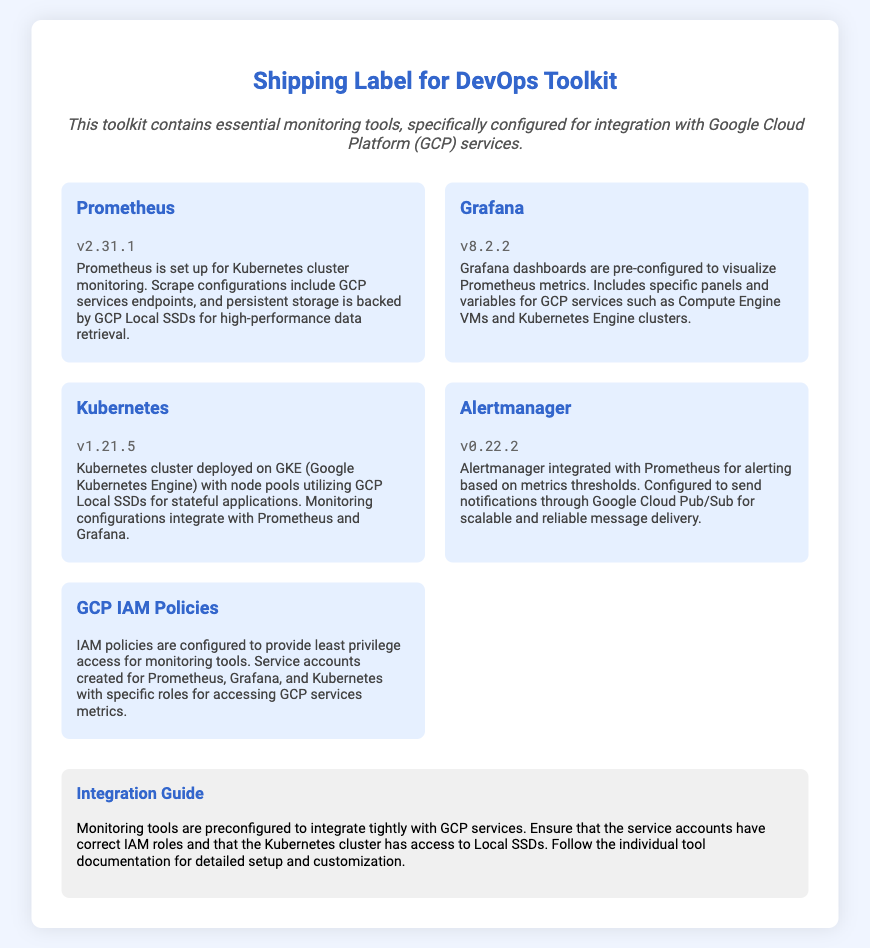What is the version of Prometheus? The version of Prometheus listed in the document is v2.31.1.
Answer: v2.31.1 What is the main purpose of Alertmanager? Alertmanager is integrated with Prometheus for alerting based on metrics thresholds.
Answer: Alerting Which Kubernetes version is mentioned? The document specifies that Kubernetes version v1.21.5 is mentioned.
Answer: v1.21.5 What storage type is used for Prometheus in the configuration? The storage type used for Prometheus is GCP Local SSDs for high-performance data retrieval.
Answer: GCP Local SSDs How are Grafana dashboards configured? Grafana dashboards are pre-configured to visualize Prometheus metrics with specific panels for GCP services.
Answer: Pre-configured What is the integration method for notifications in Alertmanager? Alertmanager is configured to send notifications through Google Cloud Pub/Sub.
Answer: Google Cloud Pub/Sub What is required for the service accounts in relation to IAM? The service accounts require least privilege access for monitoring tools.
Answer: Least privilege access What should you follow for detailed setup and customization? The individual tool documentation should be followed for detailed setup and customization.
Answer: Individual tool documentation 